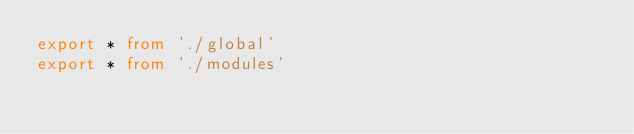<code> <loc_0><loc_0><loc_500><loc_500><_TypeScript_>export * from './global'
export * from './modules'
</code> 